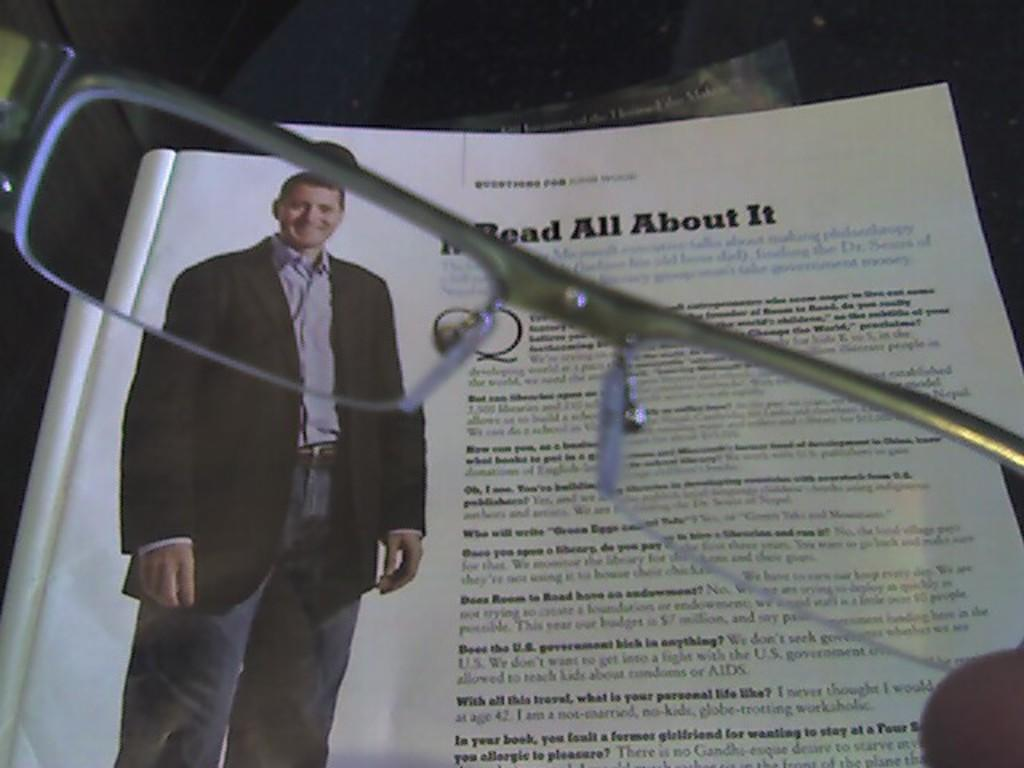What object is present in the image? There is a book in the image. What can be seen on one of the pages of the book? A person is standing in a photo on one of the pages of the book. What is the additional object visible in the image? There is a spectacle visible in the image. What type of soda is being poured into the spectacle in the image? There is no soda or pouring action present in the image. What punishment is being administered to the person in the photo on the book page? There is no indication of punishment in the image; the person is simply standing in a photo on one of the book's pages. 